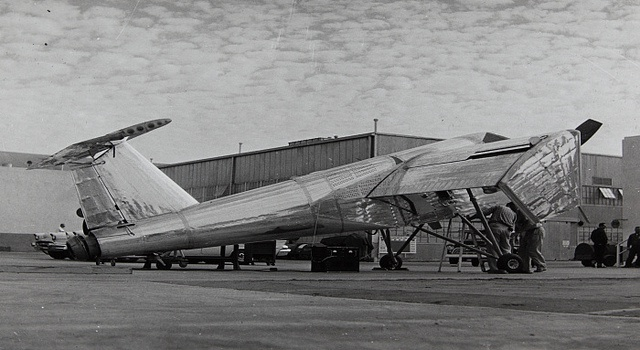Describe the objects in this image and their specific colors. I can see airplane in darkgray, gray, black, and lightgray tones, people in darkgray, black, and gray tones, people in darkgray, black, and gray tones, car in darkgray, black, and gray tones, and car in darkgray, black, and gray tones in this image. 